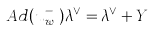Convert formula to latex. <formula><loc_0><loc_0><loc_500><loc_500>\ A d ( u ^ { - } _ { w _ { \sigma } } ) \lambda ^ { \vee } = \lambda ^ { \vee } + Y</formula> 